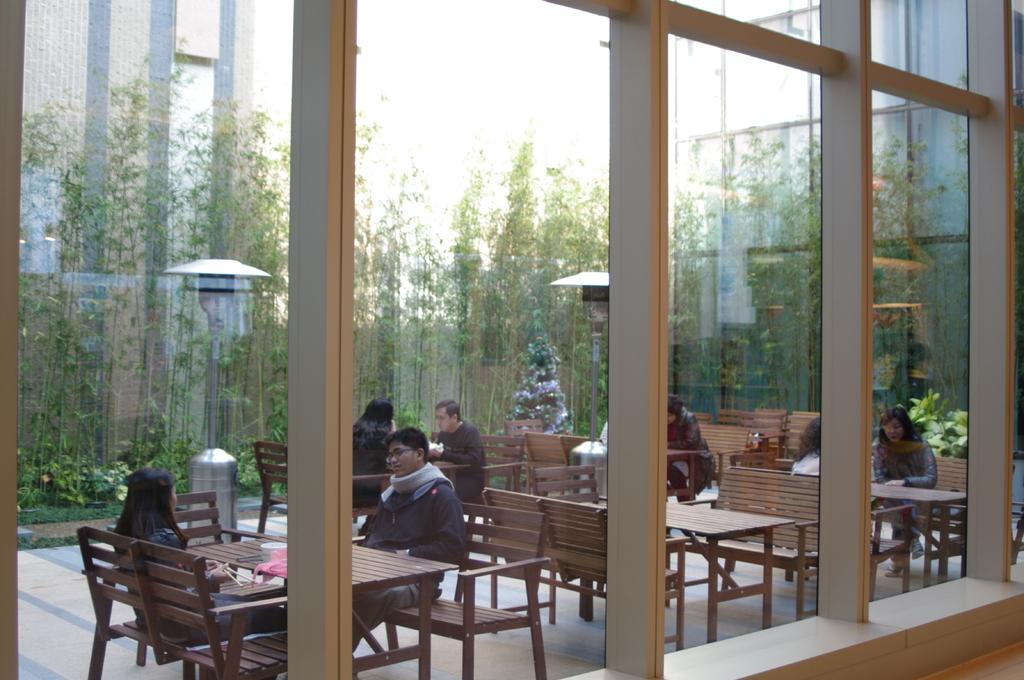Please provide a concise description of this image. The picture is taken outside of the building where there are benches and tables and at the left corner of the picture two persons are sitting on the table and there is one light and there are trees surrounded them and there are building and there is one big glass window. 